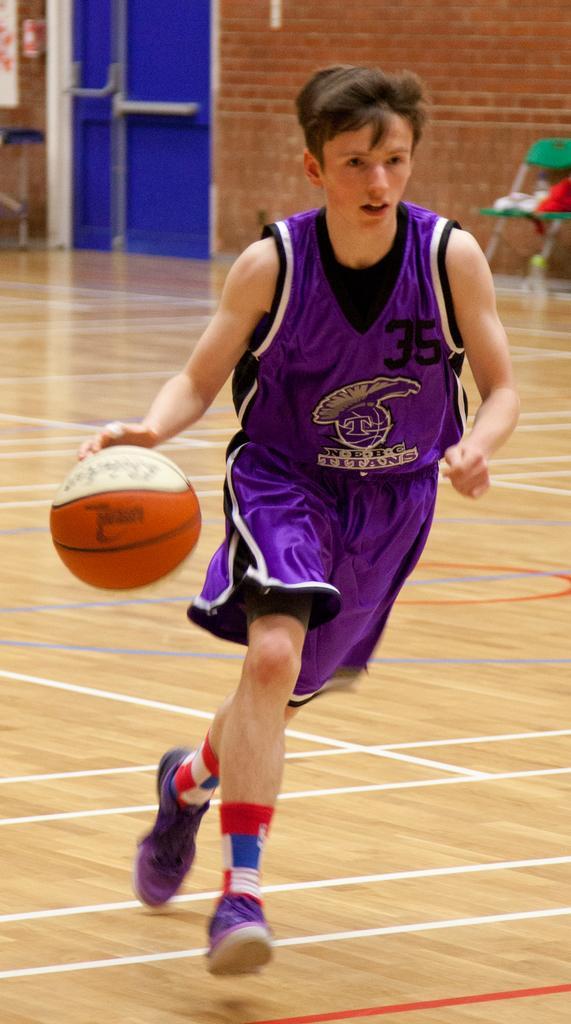Can you describe this image briefly? In the image there is a boy in purple jersey and shorts running on the basketball field with a basketball in his hand and in the back there is a brick wall with chair in front of it and a door on the left side. 